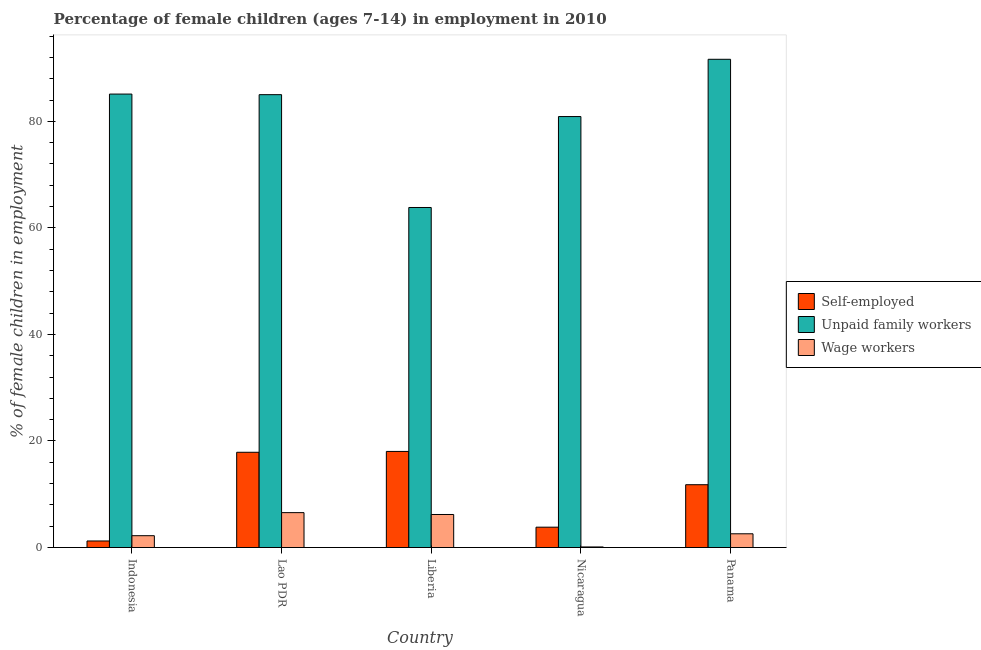How many different coloured bars are there?
Offer a terse response. 3. How many groups of bars are there?
Offer a very short reply. 5. Are the number of bars per tick equal to the number of legend labels?
Provide a short and direct response. Yes. Are the number of bars on each tick of the X-axis equal?
Provide a short and direct response. Yes. How many bars are there on the 2nd tick from the right?
Give a very brief answer. 3. What is the label of the 4th group of bars from the left?
Keep it short and to the point. Nicaragua. In how many cases, is the number of bars for a given country not equal to the number of legend labels?
Offer a very short reply. 0. What is the percentage of children employed as wage workers in Panama?
Provide a succinct answer. 2.58. Across all countries, what is the maximum percentage of children employed as wage workers?
Your answer should be very brief. 6.55. Across all countries, what is the minimum percentage of children employed as unpaid family workers?
Provide a short and direct response. 63.83. In which country was the percentage of children employed as unpaid family workers maximum?
Keep it short and to the point. Panama. What is the total percentage of self employed children in the graph?
Provide a short and direct response. 52.76. What is the difference between the percentage of children employed as unpaid family workers in Indonesia and that in Panama?
Make the answer very short. -6.53. What is the difference between the percentage of children employed as unpaid family workers in Liberia and the percentage of self employed children in Nicaragua?
Your answer should be very brief. 60.01. What is the average percentage of self employed children per country?
Your response must be concise. 10.55. What is the difference between the percentage of self employed children and percentage of children employed as wage workers in Nicaragua?
Offer a terse response. 3.71. In how many countries, is the percentage of self employed children greater than 84 %?
Your answer should be very brief. 0. What is the ratio of the percentage of self employed children in Nicaragua to that in Panama?
Your answer should be compact. 0.32. Is the difference between the percentage of children employed as unpaid family workers in Liberia and Panama greater than the difference between the percentage of children employed as wage workers in Liberia and Panama?
Ensure brevity in your answer.  No. What is the difference between the highest and the second highest percentage of self employed children?
Provide a succinct answer. 0.16. What is the difference between the highest and the lowest percentage of self employed children?
Provide a succinct answer. 16.81. What does the 2nd bar from the left in Liberia represents?
Offer a terse response. Unpaid family workers. What does the 2nd bar from the right in Indonesia represents?
Offer a terse response. Unpaid family workers. Are the values on the major ticks of Y-axis written in scientific E-notation?
Offer a terse response. No. Does the graph contain any zero values?
Offer a very short reply. No. Where does the legend appear in the graph?
Provide a short and direct response. Center right. How are the legend labels stacked?
Provide a succinct answer. Vertical. What is the title of the graph?
Your answer should be compact. Percentage of female children (ages 7-14) in employment in 2010. What is the label or title of the X-axis?
Your response must be concise. Country. What is the label or title of the Y-axis?
Your response must be concise. % of female children in employment. What is the % of female children in employment in Self-employed in Indonesia?
Your response must be concise. 1.23. What is the % of female children in employment of Unpaid family workers in Indonesia?
Your answer should be very brief. 85.12. What is the % of female children in employment in Wage workers in Indonesia?
Ensure brevity in your answer.  2.22. What is the % of female children in employment in Self-employed in Lao PDR?
Provide a short and direct response. 17.88. What is the % of female children in employment of Unpaid family workers in Lao PDR?
Your answer should be compact. 85.01. What is the % of female children in employment of Wage workers in Lao PDR?
Offer a very short reply. 6.55. What is the % of female children in employment in Self-employed in Liberia?
Your answer should be compact. 18.04. What is the % of female children in employment in Unpaid family workers in Liberia?
Keep it short and to the point. 63.83. What is the % of female children in employment of Self-employed in Nicaragua?
Offer a terse response. 3.82. What is the % of female children in employment in Unpaid family workers in Nicaragua?
Offer a terse response. 80.9. What is the % of female children in employment in Wage workers in Nicaragua?
Provide a succinct answer. 0.11. What is the % of female children in employment in Self-employed in Panama?
Offer a terse response. 11.79. What is the % of female children in employment of Unpaid family workers in Panama?
Your response must be concise. 91.65. What is the % of female children in employment of Wage workers in Panama?
Provide a short and direct response. 2.58. Across all countries, what is the maximum % of female children in employment in Self-employed?
Provide a succinct answer. 18.04. Across all countries, what is the maximum % of female children in employment of Unpaid family workers?
Your answer should be very brief. 91.65. Across all countries, what is the maximum % of female children in employment in Wage workers?
Provide a succinct answer. 6.55. Across all countries, what is the minimum % of female children in employment of Self-employed?
Ensure brevity in your answer.  1.23. Across all countries, what is the minimum % of female children in employment in Unpaid family workers?
Offer a terse response. 63.83. Across all countries, what is the minimum % of female children in employment in Wage workers?
Ensure brevity in your answer.  0.11. What is the total % of female children in employment of Self-employed in the graph?
Your answer should be very brief. 52.76. What is the total % of female children in employment in Unpaid family workers in the graph?
Your answer should be very brief. 406.51. What is the total % of female children in employment in Wage workers in the graph?
Offer a terse response. 17.66. What is the difference between the % of female children in employment of Self-employed in Indonesia and that in Lao PDR?
Offer a very short reply. -16.65. What is the difference between the % of female children in employment of Unpaid family workers in Indonesia and that in Lao PDR?
Your answer should be compact. 0.11. What is the difference between the % of female children in employment in Wage workers in Indonesia and that in Lao PDR?
Offer a very short reply. -4.33. What is the difference between the % of female children in employment of Self-employed in Indonesia and that in Liberia?
Your response must be concise. -16.81. What is the difference between the % of female children in employment of Unpaid family workers in Indonesia and that in Liberia?
Make the answer very short. 21.29. What is the difference between the % of female children in employment of Wage workers in Indonesia and that in Liberia?
Provide a short and direct response. -3.98. What is the difference between the % of female children in employment in Self-employed in Indonesia and that in Nicaragua?
Give a very brief answer. -2.59. What is the difference between the % of female children in employment of Unpaid family workers in Indonesia and that in Nicaragua?
Provide a succinct answer. 4.22. What is the difference between the % of female children in employment of Wage workers in Indonesia and that in Nicaragua?
Keep it short and to the point. 2.11. What is the difference between the % of female children in employment of Self-employed in Indonesia and that in Panama?
Make the answer very short. -10.56. What is the difference between the % of female children in employment in Unpaid family workers in Indonesia and that in Panama?
Your answer should be very brief. -6.53. What is the difference between the % of female children in employment in Wage workers in Indonesia and that in Panama?
Your answer should be very brief. -0.36. What is the difference between the % of female children in employment of Self-employed in Lao PDR and that in Liberia?
Keep it short and to the point. -0.16. What is the difference between the % of female children in employment in Unpaid family workers in Lao PDR and that in Liberia?
Give a very brief answer. 21.18. What is the difference between the % of female children in employment of Self-employed in Lao PDR and that in Nicaragua?
Make the answer very short. 14.06. What is the difference between the % of female children in employment in Unpaid family workers in Lao PDR and that in Nicaragua?
Your answer should be compact. 4.11. What is the difference between the % of female children in employment in Wage workers in Lao PDR and that in Nicaragua?
Offer a very short reply. 6.44. What is the difference between the % of female children in employment of Self-employed in Lao PDR and that in Panama?
Keep it short and to the point. 6.09. What is the difference between the % of female children in employment in Unpaid family workers in Lao PDR and that in Panama?
Keep it short and to the point. -6.64. What is the difference between the % of female children in employment of Wage workers in Lao PDR and that in Panama?
Give a very brief answer. 3.97. What is the difference between the % of female children in employment in Self-employed in Liberia and that in Nicaragua?
Give a very brief answer. 14.22. What is the difference between the % of female children in employment of Unpaid family workers in Liberia and that in Nicaragua?
Give a very brief answer. -17.07. What is the difference between the % of female children in employment in Wage workers in Liberia and that in Nicaragua?
Offer a very short reply. 6.09. What is the difference between the % of female children in employment of Self-employed in Liberia and that in Panama?
Your answer should be very brief. 6.25. What is the difference between the % of female children in employment of Unpaid family workers in Liberia and that in Panama?
Provide a short and direct response. -27.82. What is the difference between the % of female children in employment in Wage workers in Liberia and that in Panama?
Give a very brief answer. 3.62. What is the difference between the % of female children in employment in Self-employed in Nicaragua and that in Panama?
Your answer should be compact. -7.97. What is the difference between the % of female children in employment of Unpaid family workers in Nicaragua and that in Panama?
Keep it short and to the point. -10.75. What is the difference between the % of female children in employment in Wage workers in Nicaragua and that in Panama?
Give a very brief answer. -2.47. What is the difference between the % of female children in employment in Self-employed in Indonesia and the % of female children in employment in Unpaid family workers in Lao PDR?
Ensure brevity in your answer.  -83.78. What is the difference between the % of female children in employment in Self-employed in Indonesia and the % of female children in employment in Wage workers in Lao PDR?
Your response must be concise. -5.32. What is the difference between the % of female children in employment in Unpaid family workers in Indonesia and the % of female children in employment in Wage workers in Lao PDR?
Ensure brevity in your answer.  78.57. What is the difference between the % of female children in employment in Self-employed in Indonesia and the % of female children in employment in Unpaid family workers in Liberia?
Make the answer very short. -62.6. What is the difference between the % of female children in employment in Self-employed in Indonesia and the % of female children in employment in Wage workers in Liberia?
Keep it short and to the point. -4.97. What is the difference between the % of female children in employment of Unpaid family workers in Indonesia and the % of female children in employment of Wage workers in Liberia?
Provide a short and direct response. 78.92. What is the difference between the % of female children in employment in Self-employed in Indonesia and the % of female children in employment in Unpaid family workers in Nicaragua?
Make the answer very short. -79.67. What is the difference between the % of female children in employment in Self-employed in Indonesia and the % of female children in employment in Wage workers in Nicaragua?
Keep it short and to the point. 1.12. What is the difference between the % of female children in employment of Unpaid family workers in Indonesia and the % of female children in employment of Wage workers in Nicaragua?
Ensure brevity in your answer.  85.01. What is the difference between the % of female children in employment of Self-employed in Indonesia and the % of female children in employment of Unpaid family workers in Panama?
Your response must be concise. -90.42. What is the difference between the % of female children in employment of Self-employed in Indonesia and the % of female children in employment of Wage workers in Panama?
Keep it short and to the point. -1.35. What is the difference between the % of female children in employment in Unpaid family workers in Indonesia and the % of female children in employment in Wage workers in Panama?
Give a very brief answer. 82.54. What is the difference between the % of female children in employment of Self-employed in Lao PDR and the % of female children in employment of Unpaid family workers in Liberia?
Offer a terse response. -45.95. What is the difference between the % of female children in employment of Self-employed in Lao PDR and the % of female children in employment of Wage workers in Liberia?
Ensure brevity in your answer.  11.68. What is the difference between the % of female children in employment in Unpaid family workers in Lao PDR and the % of female children in employment in Wage workers in Liberia?
Make the answer very short. 78.81. What is the difference between the % of female children in employment of Self-employed in Lao PDR and the % of female children in employment of Unpaid family workers in Nicaragua?
Your response must be concise. -63.02. What is the difference between the % of female children in employment in Self-employed in Lao PDR and the % of female children in employment in Wage workers in Nicaragua?
Provide a succinct answer. 17.77. What is the difference between the % of female children in employment in Unpaid family workers in Lao PDR and the % of female children in employment in Wage workers in Nicaragua?
Keep it short and to the point. 84.9. What is the difference between the % of female children in employment in Self-employed in Lao PDR and the % of female children in employment in Unpaid family workers in Panama?
Your response must be concise. -73.77. What is the difference between the % of female children in employment in Self-employed in Lao PDR and the % of female children in employment in Wage workers in Panama?
Give a very brief answer. 15.3. What is the difference between the % of female children in employment of Unpaid family workers in Lao PDR and the % of female children in employment of Wage workers in Panama?
Provide a succinct answer. 82.43. What is the difference between the % of female children in employment of Self-employed in Liberia and the % of female children in employment of Unpaid family workers in Nicaragua?
Offer a terse response. -62.86. What is the difference between the % of female children in employment in Self-employed in Liberia and the % of female children in employment in Wage workers in Nicaragua?
Your answer should be compact. 17.93. What is the difference between the % of female children in employment of Unpaid family workers in Liberia and the % of female children in employment of Wage workers in Nicaragua?
Give a very brief answer. 63.72. What is the difference between the % of female children in employment in Self-employed in Liberia and the % of female children in employment in Unpaid family workers in Panama?
Ensure brevity in your answer.  -73.61. What is the difference between the % of female children in employment in Self-employed in Liberia and the % of female children in employment in Wage workers in Panama?
Provide a short and direct response. 15.46. What is the difference between the % of female children in employment of Unpaid family workers in Liberia and the % of female children in employment of Wage workers in Panama?
Offer a very short reply. 61.25. What is the difference between the % of female children in employment in Self-employed in Nicaragua and the % of female children in employment in Unpaid family workers in Panama?
Provide a succinct answer. -87.83. What is the difference between the % of female children in employment in Self-employed in Nicaragua and the % of female children in employment in Wage workers in Panama?
Make the answer very short. 1.24. What is the difference between the % of female children in employment in Unpaid family workers in Nicaragua and the % of female children in employment in Wage workers in Panama?
Keep it short and to the point. 78.32. What is the average % of female children in employment in Self-employed per country?
Keep it short and to the point. 10.55. What is the average % of female children in employment of Unpaid family workers per country?
Your response must be concise. 81.3. What is the average % of female children in employment in Wage workers per country?
Offer a terse response. 3.53. What is the difference between the % of female children in employment in Self-employed and % of female children in employment in Unpaid family workers in Indonesia?
Ensure brevity in your answer.  -83.89. What is the difference between the % of female children in employment of Self-employed and % of female children in employment of Wage workers in Indonesia?
Provide a succinct answer. -0.99. What is the difference between the % of female children in employment of Unpaid family workers and % of female children in employment of Wage workers in Indonesia?
Make the answer very short. 82.9. What is the difference between the % of female children in employment of Self-employed and % of female children in employment of Unpaid family workers in Lao PDR?
Your response must be concise. -67.13. What is the difference between the % of female children in employment in Self-employed and % of female children in employment in Wage workers in Lao PDR?
Your answer should be very brief. 11.33. What is the difference between the % of female children in employment of Unpaid family workers and % of female children in employment of Wage workers in Lao PDR?
Provide a succinct answer. 78.46. What is the difference between the % of female children in employment in Self-employed and % of female children in employment in Unpaid family workers in Liberia?
Provide a succinct answer. -45.79. What is the difference between the % of female children in employment of Self-employed and % of female children in employment of Wage workers in Liberia?
Offer a very short reply. 11.84. What is the difference between the % of female children in employment in Unpaid family workers and % of female children in employment in Wage workers in Liberia?
Provide a short and direct response. 57.63. What is the difference between the % of female children in employment in Self-employed and % of female children in employment in Unpaid family workers in Nicaragua?
Your response must be concise. -77.08. What is the difference between the % of female children in employment in Self-employed and % of female children in employment in Wage workers in Nicaragua?
Ensure brevity in your answer.  3.71. What is the difference between the % of female children in employment in Unpaid family workers and % of female children in employment in Wage workers in Nicaragua?
Your response must be concise. 80.79. What is the difference between the % of female children in employment in Self-employed and % of female children in employment in Unpaid family workers in Panama?
Your answer should be very brief. -79.86. What is the difference between the % of female children in employment of Self-employed and % of female children in employment of Wage workers in Panama?
Your response must be concise. 9.21. What is the difference between the % of female children in employment of Unpaid family workers and % of female children in employment of Wage workers in Panama?
Make the answer very short. 89.07. What is the ratio of the % of female children in employment in Self-employed in Indonesia to that in Lao PDR?
Provide a short and direct response. 0.07. What is the ratio of the % of female children in employment of Wage workers in Indonesia to that in Lao PDR?
Provide a short and direct response. 0.34. What is the ratio of the % of female children in employment in Self-employed in Indonesia to that in Liberia?
Your answer should be compact. 0.07. What is the ratio of the % of female children in employment in Unpaid family workers in Indonesia to that in Liberia?
Keep it short and to the point. 1.33. What is the ratio of the % of female children in employment in Wage workers in Indonesia to that in Liberia?
Offer a terse response. 0.36. What is the ratio of the % of female children in employment in Self-employed in Indonesia to that in Nicaragua?
Provide a succinct answer. 0.32. What is the ratio of the % of female children in employment of Unpaid family workers in Indonesia to that in Nicaragua?
Your answer should be very brief. 1.05. What is the ratio of the % of female children in employment in Wage workers in Indonesia to that in Nicaragua?
Offer a terse response. 20.18. What is the ratio of the % of female children in employment of Self-employed in Indonesia to that in Panama?
Your answer should be very brief. 0.1. What is the ratio of the % of female children in employment of Unpaid family workers in Indonesia to that in Panama?
Provide a short and direct response. 0.93. What is the ratio of the % of female children in employment in Wage workers in Indonesia to that in Panama?
Keep it short and to the point. 0.86. What is the ratio of the % of female children in employment in Unpaid family workers in Lao PDR to that in Liberia?
Ensure brevity in your answer.  1.33. What is the ratio of the % of female children in employment in Wage workers in Lao PDR to that in Liberia?
Make the answer very short. 1.06. What is the ratio of the % of female children in employment in Self-employed in Lao PDR to that in Nicaragua?
Your answer should be compact. 4.68. What is the ratio of the % of female children in employment of Unpaid family workers in Lao PDR to that in Nicaragua?
Keep it short and to the point. 1.05. What is the ratio of the % of female children in employment in Wage workers in Lao PDR to that in Nicaragua?
Provide a short and direct response. 59.55. What is the ratio of the % of female children in employment of Self-employed in Lao PDR to that in Panama?
Keep it short and to the point. 1.52. What is the ratio of the % of female children in employment in Unpaid family workers in Lao PDR to that in Panama?
Your response must be concise. 0.93. What is the ratio of the % of female children in employment of Wage workers in Lao PDR to that in Panama?
Offer a terse response. 2.54. What is the ratio of the % of female children in employment of Self-employed in Liberia to that in Nicaragua?
Your answer should be very brief. 4.72. What is the ratio of the % of female children in employment of Unpaid family workers in Liberia to that in Nicaragua?
Make the answer very short. 0.79. What is the ratio of the % of female children in employment in Wage workers in Liberia to that in Nicaragua?
Offer a very short reply. 56.36. What is the ratio of the % of female children in employment in Self-employed in Liberia to that in Panama?
Ensure brevity in your answer.  1.53. What is the ratio of the % of female children in employment of Unpaid family workers in Liberia to that in Panama?
Provide a succinct answer. 0.7. What is the ratio of the % of female children in employment of Wage workers in Liberia to that in Panama?
Ensure brevity in your answer.  2.4. What is the ratio of the % of female children in employment of Self-employed in Nicaragua to that in Panama?
Make the answer very short. 0.32. What is the ratio of the % of female children in employment of Unpaid family workers in Nicaragua to that in Panama?
Keep it short and to the point. 0.88. What is the ratio of the % of female children in employment of Wage workers in Nicaragua to that in Panama?
Give a very brief answer. 0.04. What is the difference between the highest and the second highest % of female children in employment of Self-employed?
Make the answer very short. 0.16. What is the difference between the highest and the second highest % of female children in employment in Unpaid family workers?
Your response must be concise. 6.53. What is the difference between the highest and the second highest % of female children in employment in Wage workers?
Your answer should be compact. 0.35. What is the difference between the highest and the lowest % of female children in employment in Self-employed?
Your answer should be compact. 16.81. What is the difference between the highest and the lowest % of female children in employment in Unpaid family workers?
Give a very brief answer. 27.82. What is the difference between the highest and the lowest % of female children in employment of Wage workers?
Ensure brevity in your answer.  6.44. 